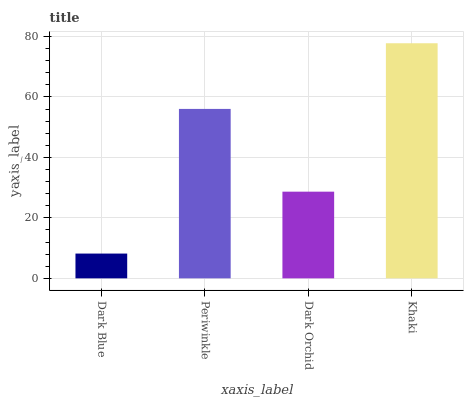Is Dark Blue the minimum?
Answer yes or no. Yes. Is Khaki the maximum?
Answer yes or no. Yes. Is Periwinkle the minimum?
Answer yes or no. No. Is Periwinkle the maximum?
Answer yes or no. No. Is Periwinkle greater than Dark Blue?
Answer yes or no. Yes. Is Dark Blue less than Periwinkle?
Answer yes or no. Yes. Is Dark Blue greater than Periwinkle?
Answer yes or no. No. Is Periwinkle less than Dark Blue?
Answer yes or no. No. Is Periwinkle the high median?
Answer yes or no. Yes. Is Dark Orchid the low median?
Answer yes or no. Yes. Is Dark Blue the high median?
Answer yes or no. No. Is Dark Blue the low median?
Answer yes or no. No. 